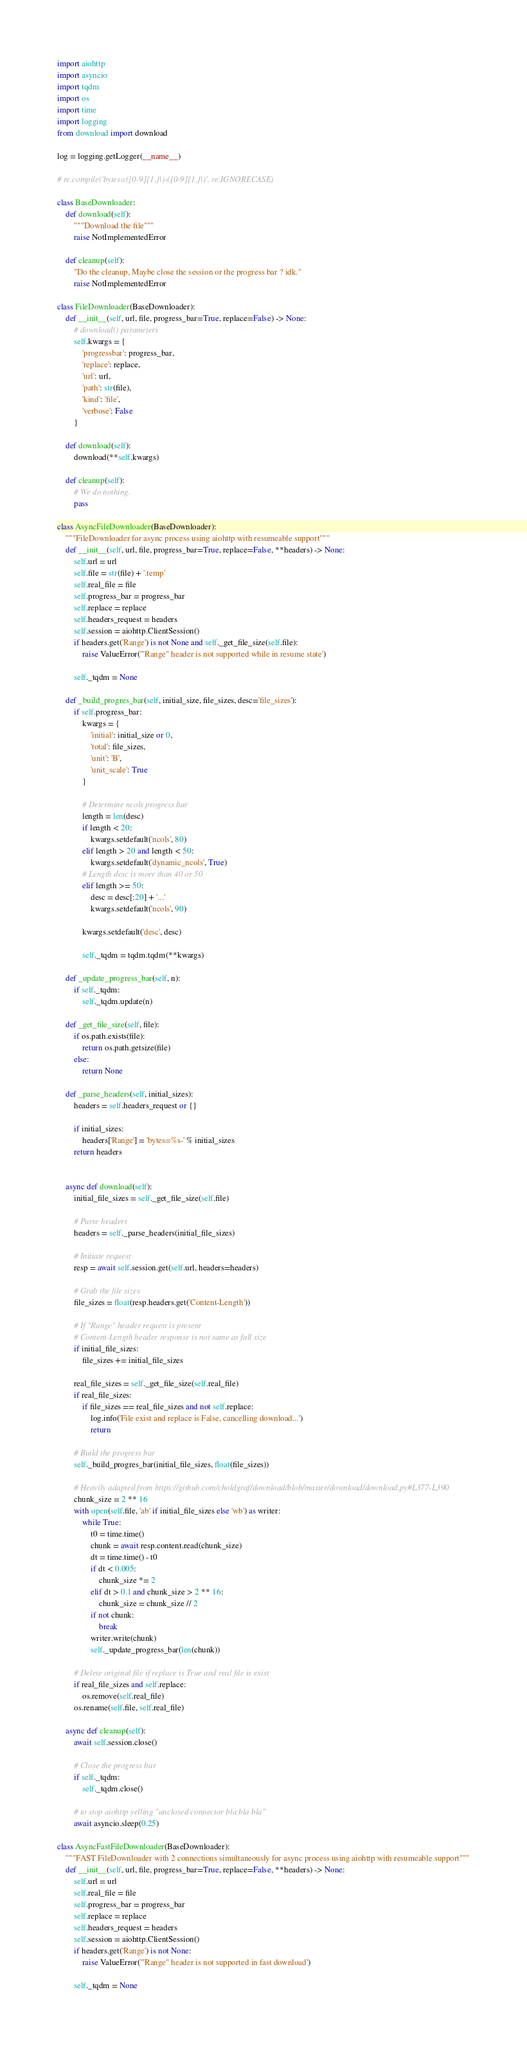<code> <loc_0><loc_0><loc_500><loc_500><_Python_>import aiohttp
import asyncio
import tqdm
import os
import time
import logging
from download import download

log = logging.getLogger(__name__)

# re.compile('bytes=([0-9]{1,}|)-([0-9]{1,}|)', re.IGNORECASE)

class BaseDownloader:
    def download(self):
        """Download the file"""
        raise NotImplementedError

    def cleanup(self):
        "Do the cleanup, Maybe close the session or the progress bar ? idk."
        raise NotImplementedError

class FileDownloader(BaseDownloader):
    def __init__(self, url, file, progress_bar=True, replace=False) -> None:
        # download() parameters
        self.kwargs = {
            'progressbar': progress_bar,
            'replace': replace,
            'url': url,
            'path': str(file),
            'kind': 'file',
            'verbose': False
        }

    def download(self):
        download(**self.kwargs)

    def cleanup(self):
        # We do nothing.
        pass

class AsyncFileDownloader(BaseDownloader):
    """FileDownloader for async process using aiohttp with resumeable support"""
    def __init__(self, url, file, progress_bar=True, replace=False, **headers) -> None:
        self.url = url
        self.file = str(file) + '.temp'
        self.real_file = file
        self.progress_bar = progress_bar
        self.replace = replace
        self.headers_request = headers
        self.session = aiohttp.ClientSession()
        if headers.get('Range') is not None and self._get_file_size(self.file):
            raise ValueError('"Range" header is not supported while in resume state')

        self._tqdm = None
    
    def _build_progres_bar(self, initial_size, file_sizes, desc='file_sizes'):
        if self.progress_bar:
            kwargs = {
                'initial': initial_size or 0,
                'total': file_sizes,
                'unit': 'B',
                'unit_scale': True
            }

            # Determine ncols progress bar
            length = len(desc)
            if length < 20:
                kwargs.setdefault('ncols', 80)
            elif length > 20 and length < 50:
                kwargs.setdefault('dynamic_ncols', True)
            # Length desc is more than 40 or 50
            elif length >= 50:
                desc = desc[:20] + '...'
                kwargs.setdefault('ncols', 90)

            kwargs.setdefault('desc', desc)

            self._tqdm = tqdm.tqdm(**kwargs)

    def _update_progress_bar(self, n):
        if self._tqdm:
            self._tqdm.update(n)

    def _get_file_size(self, file):
        if os.path.exists(file):
            return os.path.getsize(file)
        else:
            return None

    def _parse_headers(self, initial_sizes):
        headers = self.headers_request or {}

        if initial_sizes:
            headers['Range'] = 'bytes=%s-' % initial_sizes
        return headers
        

    async def download(self):
        initial_file_sizes = self._get_file_size(self.file)

        # Parse headers
        headers = self._parse_headers(initial_file_sizes)

        # Initiate request
        resp = await self.session.get(self.url, headers=headers)

        # Grab the file sizes
        file_sizes = float(resp.headers.get('Content-Length'))

        # If "Range" header request is present
        # Content-Length header response is not same as full size
        if initial_file_sizes:
            file_sizes += initial_file_sizes

        real_file_sizes = self._get_file_size(self.real_file)
        if real_file_sizes:
            if file_sizes == real_file_sizes and not self.replace:
                log.info('File exist and replace is False, cancelling download...')
                return

        # Build the progress bar
        self._build_progres_bar(initial_file_sizes, float(file_sizes))

        # Heavily adapted from https://github.com/choldgraf/download/blob/master/download/download.py#L377-L390
        chunk_size = 2 ** 16
        with open(self.file, 'ab' if initial_file_sizes else 'wb') as writer:
            while True:
                t0 = time.time()
                chunk = await resp.content.read(chunk_size)
                dt = time.time() - t0
                if dt < 0.005:
                    chunk_size *= 2
                elif dt > 0.1 and chunk_size > 2 ** 16:
                    chunk_size = chunk_size // 2
                if not chunk:
                    break
                writer.write(chunk)
                self._update_progress_bar(len(chunk))
        
        # Delete original file if replace is True and real file is exist
        if real_file_sizes and self.replace:
            os.remove(self.real_file)
        os.rename(self.file, self.real_file)

    async def cleanup(self):
        await self.session.close()

        # Close the progress bar
        if self._tqdm:
            self._tqdm.close()

        # to stop aiohttp yelling "unclosed connector bla bla bla"
        await asyncio.sleep(0.25)

class AsyncFastFileDownloader(BaseDownloader):
    """FAST FileDownloader with 2 connections simultaneously for async process using aiohttp with resumeable support"""
    def __init__(self, url, file, progress_bar=True, replace=False, **headers) -> None:
        self.url = url
        self.real_file = file
        self.progress_bar = progress_bar
        self.replace = replace
        self.headers_request = headers
        self.session = aiohttp.ClientSession()
        if headers.get('Range') is not None:
            raise ValueError('"Range" header is not supported in fast download')

        self._tqdm = None
</code> 